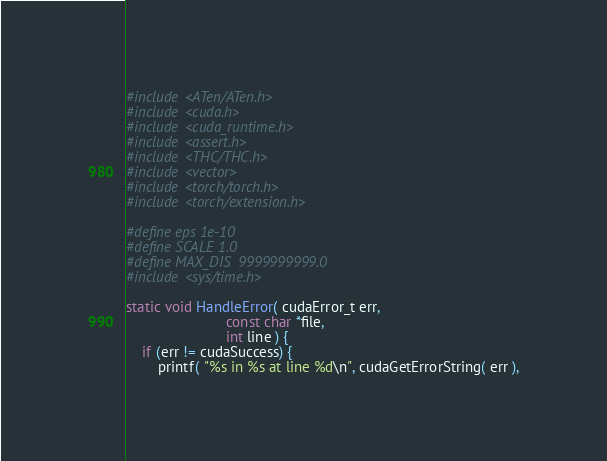Convert code to text. <code><loc_0><loc_0><loc_500><loc_500><_Cuda_>#include <ATen/ATen.h>
#include <cuda.h>
#include <cuda_runtime.h>
#include <assert.h>
#include <THC/THC.h>
#include <vector>
#include <torch/torch.h>
#include <torch/extension.h>

#define eps 1e-10
#define SCALE 1.0
#define MAX_DIS  9999999999.0
#include <sys/time.h>

static void HandleError( cudaError_t err,
                         const char *file,
                         int line ) {
    if (err != cudaSuccess) {
        printf( "%s in %s at line %d\n", cudaGetErrorString( err ),</code> 